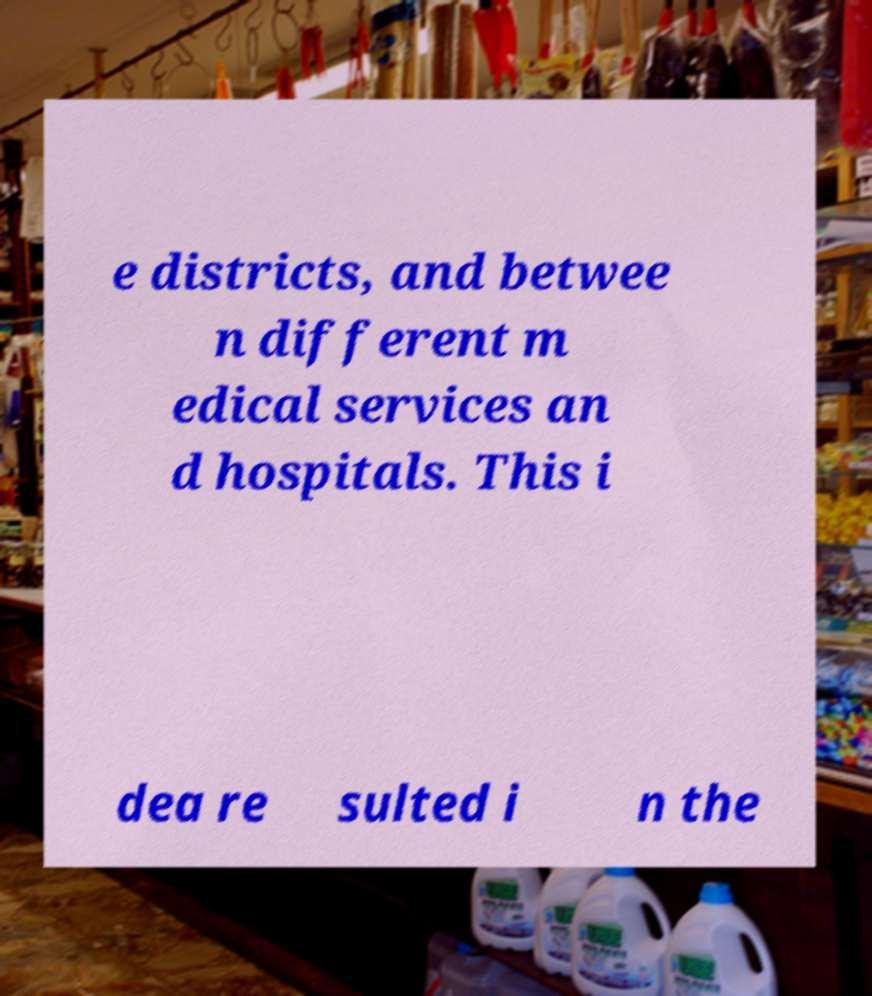Please identify and transcribe the text found in this image. e districts, and betwee n different m edical services an d hospitals. This i dea re sulted i n the 